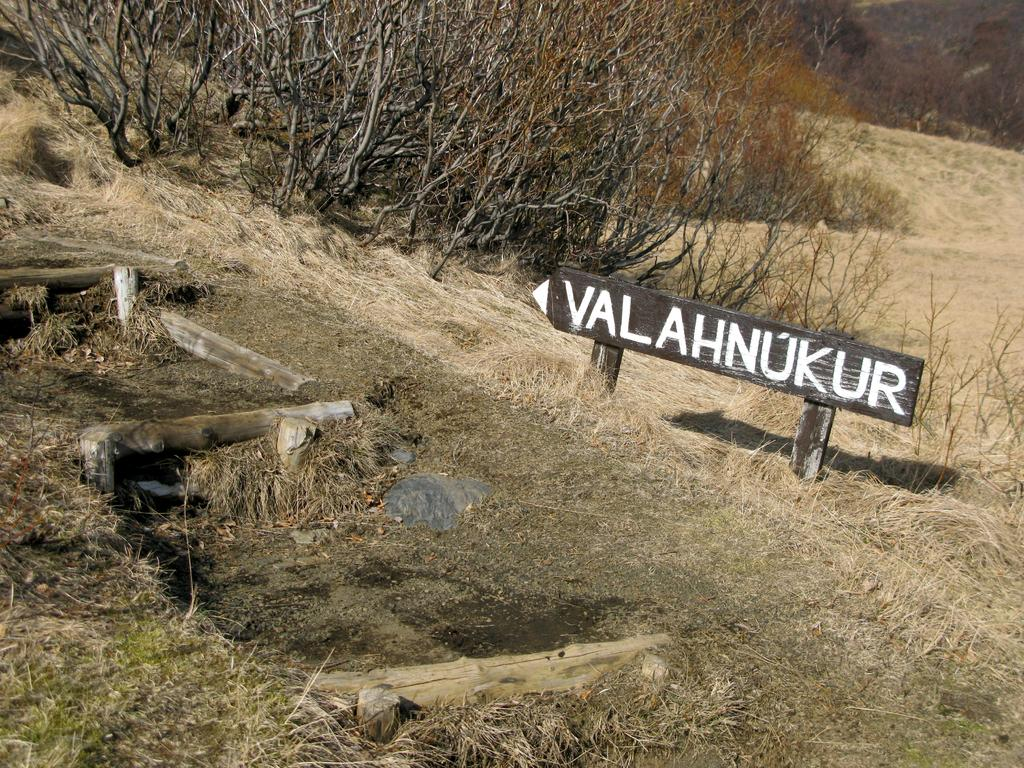What is the main object in the image? There is a sign board in the image. What type of vegetation can be seen in the image? There are dried trees in the image. What is the condition of the grass in the image? There is dried grass on the ground in the image. What is the level of the table in the image? There is no table present in the image. 